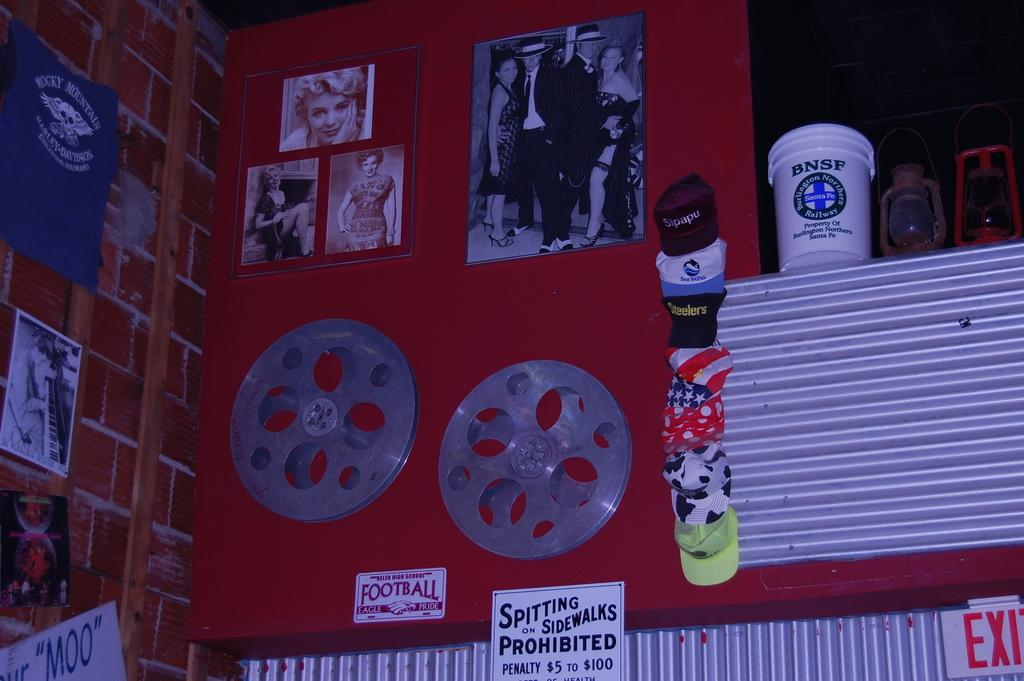Provide a one-sentence caption for the provided image. A wall of vintage items includes a sign prohibiting spitting on sidewalks. 